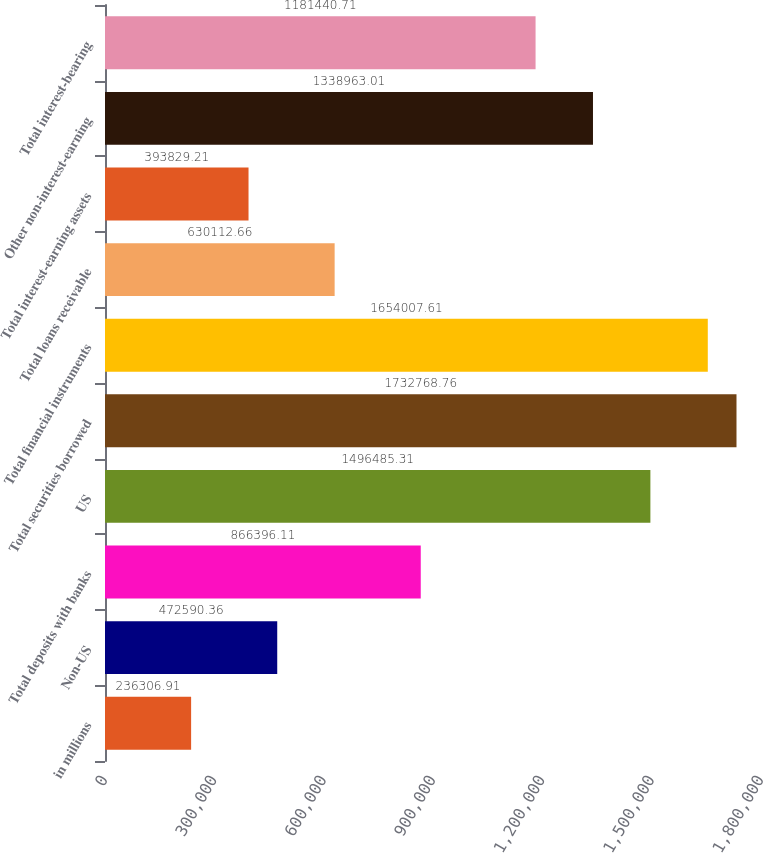Convert chart to OTSL. <chart><loc_0><loc_0><loc_500><loc_500><bar_chart><fcel>in millions<fcel>Non-US<fcel>Total deposits with banks<fcel>US<fcel>Total securities borrowed<fcel>Total financial instruments<fcel>Total loans receivable<fcel>Total interest-earning assets<fcel>Other non-interest-earning<fcel>Total interest-bearing<nl><fcel>236307<fcel>472590<fcel>866396<fcel>1.49649e+06<fcel>1.73277e+06<fcel>1.65401e+06<fcel>630113<fcel>393829<fcel>1.33896e+06<fcel>1.18144e+06<nl></chart> 